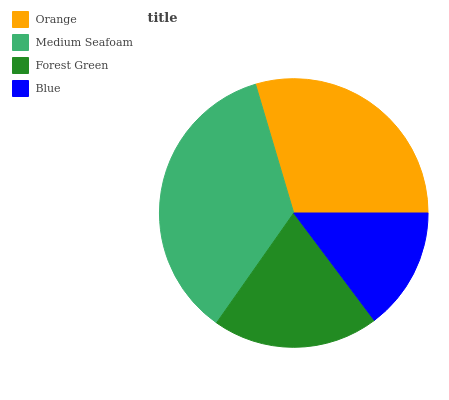Is Blue the minimum?
Answer yes or no. Yes. Is Medium Seafoam the maximum?
Answer yes or no. Yes. Is Forest Green the minimum?
Answer yes or no. No. Is Forest Green the maximum?
Answer yes or no. No. Is Medium Seafoam greater than Forest Green?
Answer yes or no. Yes. Is Forest Green less than Medium Seafoam?
Answer yes or no. Yes. Is Forest Green greater than Medium Seafoam?
Answer yes or no. No. Is Medium Seafoam less than Forest Green?
Answer yes or no. No. Is Orange the high median?
Answer yes or no. Yes. Is Forest Green the low median?
Answer yes or no. Yes. Is Forest Green the high median?
Answer yes or no. No. Is Blue the low median?
Answer yes or no. No. 